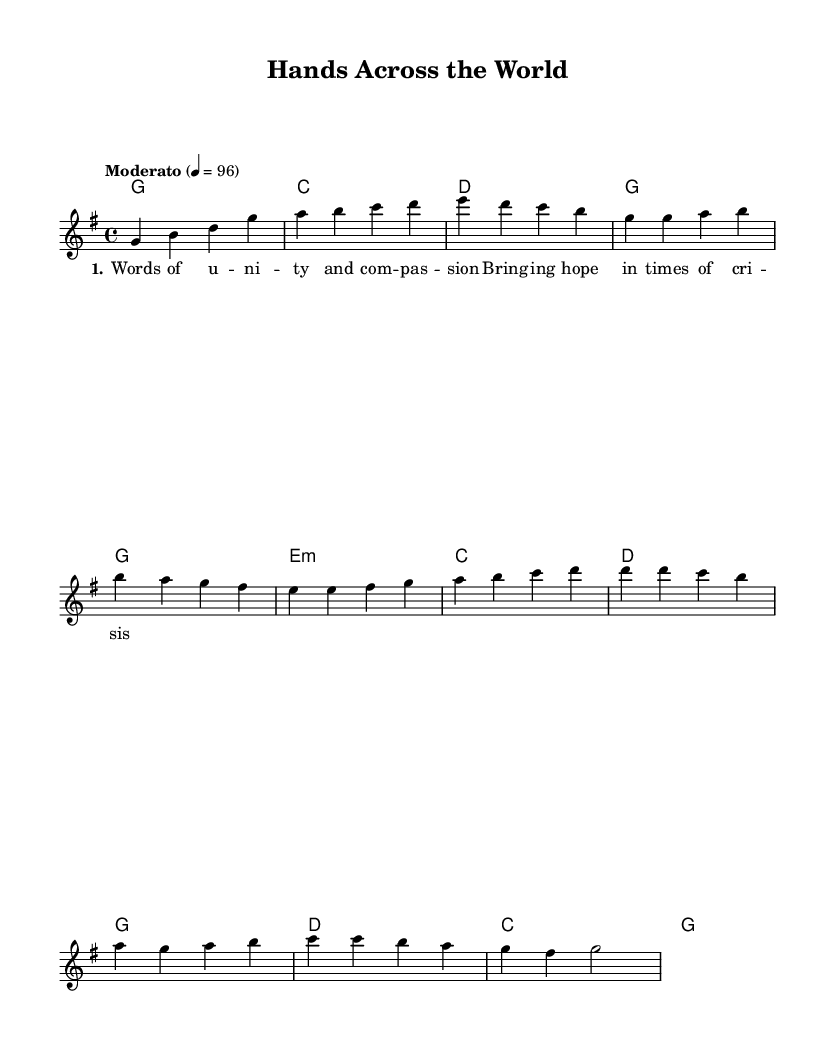What is the key signature of this music? The key signature is indicated by the absence of any sharps or flats at the beginning of the staff. In this case, it shows one sharp on the F line, indicating G major.
Answer: G major What is the time signature of the music? The time signature is the fraction-like number seen at the beginning of the score. Here, it shows a 4 over 4, which indicates four beats per measure.
Answer: 4/4 What is the tempo marking for this piece? The tempo marking is indicated at the beginning of the score, where it states "Moderato" followed by a BPM (beats per minute) indication of 96. This tells us the speed at which the piece should be played.
Answer: Moderato 4 = 96 How many measures are in the chorus section? To find the number of measures in the chorus, we look at the measured sections of the sheet music. The chorus has a total of four measures as seen in the notation.
Answer: 4 What are the first three notes of the melody? The first three notes of the melody can be found in the introductory section of the score. They are G, B, and D, which are clearly notated.
Answer: G, B, D What is the chord for the first measure? The chord is typically shown above the staff as a letter symbol. In the first measure, the chord is labeled as G, indicating that it is a G major chord.
Answer: G 